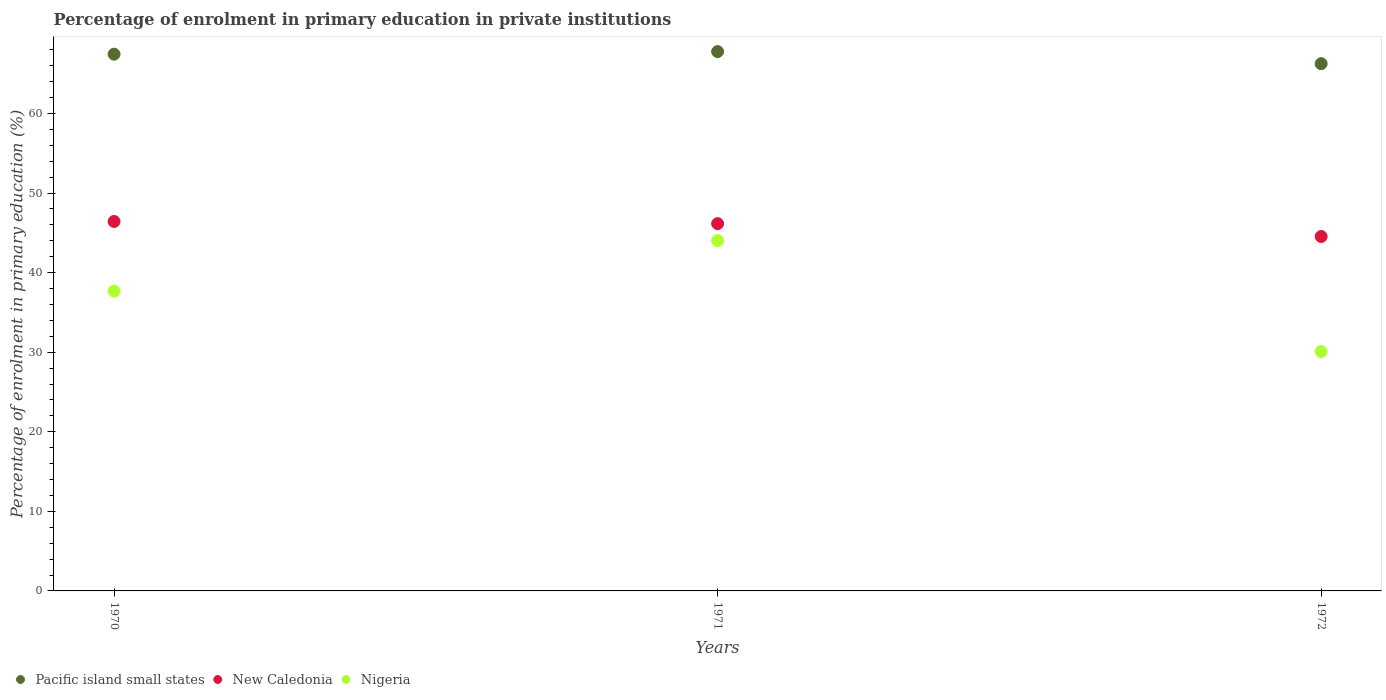Is the number of dotlines equal to the number of legend labels?
Provide a short and direct response. Yes. What is the percentage of enrolment in primary education in Pacific island small states in 1972?
Your response must be concise. 66.26. Across all years, what is the maximum percentage of enrolment in primary education in Nigeria?
Your answer should be very brief. 44.02. Across all years, what is the minimum percentage of enrolment in primary education in Nigeria?
Offer a very short reply. 30.08. In which year was the percentage of enrolment in primary education in New Caledonia maximum?
Make the answer very short. 1970. In which year was the percentage of enrolment in primary education in New Caledonia minimum?
Ensure brevity in your answer.  1972. What is the total percentage of enrolment in primary education in New Caledonia in the graph?
Your response must be concise. 137.13. What is the difference between the percentage of enrolment in primary education in Nigeria in 1971 and that in 1972?
Provide a short and direct response. 13.94. What is the difference between the percentage of enrolment in primary education in Pacific island small states in 1972 and the percentage of enrolment in primary education in New Caledonia in 1970?
Ensure brevity in your answer.  19.83. What is the average percentage of enrolment in primary education in Nigeria per year?
Offer a terse response. 37.26. In the year 1970, what is the difference between the percentage of enrolment in primary education in New Caledonia and percentage of enrolment in primary education in Pacific island small states?
Ensure brevity in your answer.  -21.02. What is the ratio of the percentage of enrolment in primary education in Nigeria in 1971 to that in 1972?
Provide a succinct answer. 1.46. What is the difference between the highest and the second highest percentage of enrolment in primary education in Pacific island small states?
Ensure brevity in your answer.  0.33. What is the difference between the highest and the lowest percentage of enrolment in primary education in New Caledonia?
Make the answer very short. 1.89. In how many years, is the percentage of enrolment in primary education in Nigeria greater than the average percentage of enrolment in primary education in Nigeria taken over all years?
Provide a short and direct response. 2. Is it the case that in every year, the sum of the percentage of enrolment in primary education in New Caledonia and percentage of enrolment in primary education in Pacific island small states  is greater than the percentage of enrolment in primary education in Nigeria?
Offer a very short reply. Yes. Is the percentage of enrolment in primary education in Nigeria strictly greater than the percentage of enrolment in primary education in Pacific island small states over the years?
Offer a terse response. No. Is the percentage of enrolment in primary education in Nigeria strictly less than the percentage of enrolment in primary education in Pacific island small states over the years?
Offer a terse response. Yes. How many dotlines are there?
Provide a succinct answer. 3. How many years are there in the graph?
Provide a succinct answer. 3. Does the graph contain grids?
Provide a short and direct response. No. How many legend labels are there?
Offer a very short reply. 3. What is the title of the graph?
Offer a very short reply. Percentage of enrolment in primary education in private institutions. What is the label or title of the Y-axis?
Offer a very short reply. Percentage of enrolment in primary education (%). What is the Percentage of enrolment in primary education (%) of Pacific island small states in 1970?
Your answer should be compact. 67.45. What is the Percentage of enrolment in primary education (%) of New Caledonia in 1970?
Ensure brevity in your answer.  46.43. What is the Percentage of enrolment in primary education (%) of Nigeria in 1970?
Your response must be concise. 37.68. What is the Percentage of enrolment in primary education (%) in Pacific island small states in 1971?
Make the answer very short. 67.78. What is the Percentage of enrolment in primary education (%) of New Caledonia in 1971?
Provide a short and direct response. 46.16. What is the Percentage of enrolment in primary education (%) of Nigeria in 1971?
Provide a succinct answer. 44.02. What is the Percentage of enrolment in primary education (%) of Pacific island small states in 1972?
Offer a very short reply. 66.26. What is the Percentage of enrolment in primary education (%) in New Caledonia in 1972?
Provide a succinct answer. 44.54. What is the Percentage of enrolment in primary education (%) of Nigeria in 1972?
Your answer should be very brief. 30.08. Across all years, what is the maximum Percentage of enrolment in primary education (%) in Pacific island small states?
Give a very brief answer. 67.78. Across all years, what is the maximum Percentage of enrolment in primary education (%) of New Caledonia?
Offer a terse response. 46.43. Across all years, what is the maximum Percentage of enrolment in primary education (%) in Nigeria?
Offer a terse response. 44.02. Across all years, what is the minimum Percentage of enrolment in primary education (%) of Pacific island small states?
Offer a very short reply. 66.26. Across all years, what is the minimum Percentage of enrolment in primary education (%) in New Caledonia?
Provide a short and direct response. 44.54. Across all years, what is the minimum Percentage of enrolment in primary education (%) of Nigeria?
Your response must be concise. 30.08. What is the total Percentage of enrolment in primary education (%) in Pacific island small states in the graph?
Your response must be concise. 201.49. What is the total Percentage of enrolment in primary education (%) of New Caledonia in the graph?
Offer a terse response. 137.13. What is the total Percentage of enrolment in primary education (%) of Nigeria in the graph?
Provide a succinct answer. 111.78. What is the difference between the Percentage of enrolment in primary education (%) of Pacific island small states in 1970 and that in 1971?
Your response must be concise. -0.33. What is the difference between the Percentage of enrolment in primary education (%) in New Caledonia in 1970 and that in 1971?
Give a very brief answer. 0.28. What is the difference between the Percentage of enrolment in primary education (%) of Nigeria in 1970 and that in 1971?
Your response must be concise. -6.34. What is the difference between the Percentage of enrolment in primary education (%) of Pacific island small states in 1970 and that in 1972?
Ensure brevity in your answer.  1.19. What is the difference between the Percentage of enrolment in primary education (%) in New Caledonia in 1970 and that in 1972?
Make the answer very short. 1.89. What is the difference between the Percentage of enrolment in primary education (%) of Nigeria in 1970 and that in 1972?
Offer a terse response. 7.59. What is the difference between the Percentage of enrolment in primary education (%) in Pacific island small states in 1971 and that in 1972?
Provide a succinct answer. 1.52. What is the difference between the Percentage of enrolment in primary education (%) in New Caledonia in 1971 and that in 1972?
Your answer should be compact. 1.61. What is the difference between the Percentage of enrolment in primary education (%) of Nigeria in 1971 and that in 1972?
Your response must be concise. 13.94. What is the difference between the Percentage of enrolment in primary education (%) of Pacific island small states in 1970 and the Percentage of enrolment in primary education (%) of New Caledonia in 1971?
Your answer should be compact. 21.3. What is the difference between the Percentage of enrolment in primary education (%) of Pacific island small states in 1970 and the Percentage of enrolment in primary education (%) of Nigeria in 1971?
Your answer should be very brief. 23.43. What is the difference between the Percentage of enrolment in primary education (%) of New Caledonia in 1970 and the Percentage of enrolment in primary education (%) of Nigeria in 1971?
Your answer should be compact. 2.41. What is the difference between the Percentage of enrolment in primary education (%) of Pacific island small states in 1970 and the Percentage of enrolment in primary education (%) of New Caledonia in 1972?
Offer a very short reply. 22.91. What is the difference between the Percentage of enrolment in primary education (%) in Pacific island small states in 1970 and the Percentage of enrolment in primary education (%) in Nigeria in 1972?
Your answer should be very brief. 37.37. What is the difference between the Percentage of enrolment in primary education (%) of New Caledonia in 1970 and the Percentage of enrolment in primary education (%) of Nigeria in 1972?
Your answer should be very brief. 16.35. What is the difference between the Percentage of enrolment in primary education (%) in Pacific island small states in 1971 and the Percentage of enrolment in primary education (%) in New Caledonia in 1972?
Your answer should be compact. 23.24. What is the difference between the Percentage of enrolment in primary education (%) of Pacific island small states in 1971 and the Percentage of enrolment in primary education (%) of Nigeria in 1972?
Provide a succinct answer. 37.7. What is the difference between the Percentage of enrolment in primary education (%) of New Caledonia in 1971 and the Percentage of enrolment in primary education (%) of Nigeria in 1972?
Your response must be concise. 16.07. What is the average Percentage of enrolment in primary education (%) of Pacific island small states per year?
Your answer should be very brief. 67.16. What is the average Percentage of enrolment in primary education (%) of New Caledonia per year?
Offer a terse response. 45.71. What is the average Percentage of enrolment in primary education (%) in Nigeria per year?
Make the answer very short. 37.26. In the year 1970, what is the difference between the Percentage of enrolment in primary education (%) of Pacific island small states and Percentage of enrolment in primary education (%) of New Caledonia?
Make the answer very short. 21.02. In the year 1970, what is the difference between the Percentage of enrolment in primary education (%) of Pacific island small states and Percentage of enrolment in primary education (%) of Nigeria?
Provide a succinct answer. 29.77. In the year 1970, what is the difference between the Percentage of enrolment in primary education (%) of New Caledonia and Percentage of enrolment in primary education (%) of Nigeria?
Provide a short and direct response. 8.75. In the year 1971, what is the difference between the Percentage of enrolment in primary education (%) in Pacific island small states and Percentage of enrolment in primary education (%) in New Caledonia?
Make the answer very short. 21.62. In the year 1971, what is the difference between the Percentage of enrolment in primary education (%) of Pacific island small states and Percentage of enrolment in primary education (%) of Nigeria?
Your answer should be very brief. 23.76. In the year 1971, what is the difference between the Percentage of enrolment in primary education (%) of New Caledonia and Percentage of enrolment in primary education (%) of Nigeria?
Keep it short and to the point. 2.13. In the year 1972, what is the difference between the Percentage of enrolment in primary education (%) in Pacific island small states and Percentage of enrolment in primary education (%) in New Caledonia?
Provide a short and direct response. 21.72. In the year 1972, what is the difference between the Percentage of enrolment in primary education (%) in Pacific island small states and Percentage of enrolment in primary education (%) in Nigeria?
Offer a very short reply. 36.18. In the year 1972, what is the difference between the Percentage of enrolment in primary education (%) of New Caledonia and Percentage of enrolment in primary education (%) of Nigeria?
Keep it short and to the point. 14.46. What is the ratio of the Percentage of enrolment in primary education (%) in Pacific island small states in 1970 to that in 1971?
Give a very brief answer. 1. What is the ratio of the Percentage of enrolment in primary education (%) in New Caledonia in 1970 to that in 1971?
Your answer should be very brief. 1.01. What is the ratio of the Percentage of enrolment in primary education (%) of Nigeria in 1970 to that in 1971?
Provide a short and direct response. 0.86. What is the ratio of the Percentage of enrolment in primary education (%) of New Caledonia in 1970 to that in 1972?
Provide a short and direct response. 1.04. What is the ratio of the Percentage of enrolment in primary education (%) in Nigeria in 1970 to that in 1972?
Provide a short and direct response. 1.25. What is the ratio of the Percentage of enrolment in primary education (%) in Pacific island small states in 1971 to that in 1972?
Keep it short and to the point. 1.02. What is the ratio of the Percentage of enrolment in primary education (%) in New Caledonia in 1971 to that in 1972?
Offer a terse response. 1.04. What is the ratio of the Percentage of enrolment in primary education (%) of Nigeria in 1971 to that in 1972?
Ensure brevity in your answer.  1.46. What is the difference between the highest and the second highest Percentage of enrolment in primary education (%) of Pacific island small states?
Keep it short and to the point. 0.33. What is the difference between the highest and the second highest Percentage of enrolment in primary education (%) of New Caledonia?
Provide a succinct answer. 0.28. What is the difference between the highest and the second highest Percentage of enrolment in primary education (%) in Nigeria?
Provide a short and direct response. 6.34. What is the difference between the highest and the lowest Percentage of enrolment in primary education (%) in Pacific island small states?
Provide a succinct answer. 1.52. What is the difference between the highest and the lowest Percentage of enrolment in primary education (%) of New Caledonia?
Provide a succinct answer. 1.89. What is the difference between the highest and the lowest Percentage of enrolment in primary education (%) of Nigeria?
Make the answer very short. 13.94. 